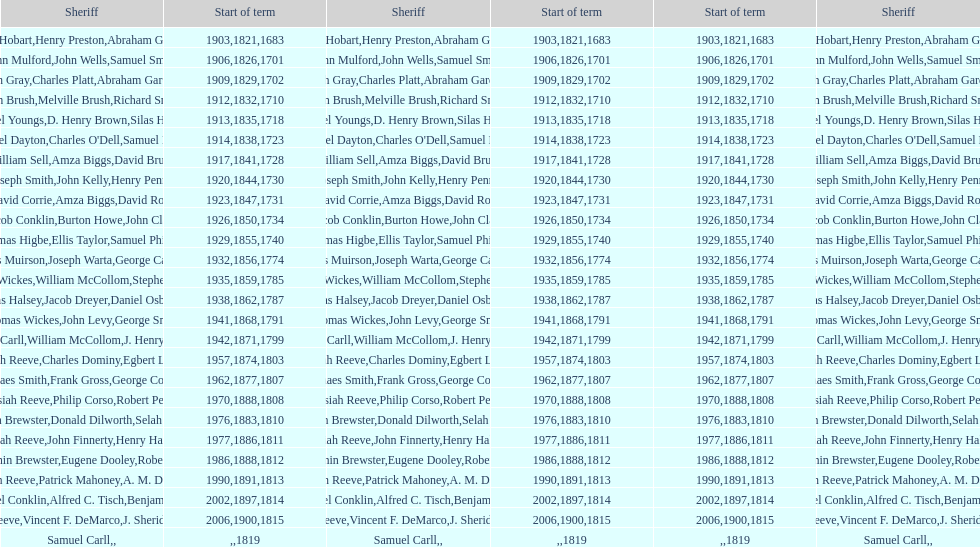Would you mind parsing the complete table? {'header': ['Sheriff', 'Start of term', 'Sheriff', 'Start of term', 'Start of term', 'Sheriff'], 'rows': [['Josiah Hobart', '1903', 'Henry Preston', '1821', '1683', 'Abraham Gardiner'], ['John Mulford', '1906', 'John Wells', '1826', '1701', 'Samuel Smith'], ['Hugh Gray', '1909', 'Charles Platt', '1829', '1702', 'Abraham Gardiner'], ['John Brush', '1912', 'Melville Brush', '1832', '1710', 'Richard Smith'], ['Daniel Youngs', '1913', 'D. Henry Brown', '1835', '1718', 'Silas Horton'], ['Samuel Dayton', '1914', "Charles O'Dell", '1838', '1723', 'Samuel Miller'], ['William Sell', '1917', 'Amza Biggs', '1841', '1728', 'David Brush'], ['Joseph Smith', '1920', 'John Kelly', '1844', '1730', 'Henry Penny'], ['David Corrie', '1923', 'Amza Biggs', '1847', '1731', 'David Rose'], ['Jacob Conklin', '1926', 'Burton Howe', '1850', '1734', 'John Clark'], ['Thomas Higbe', '1929', 'Ellis Taylor', '1855', '1740', 'Samuel Phillips'], ['James Muirson', '1932', 'Joseph Warta', '1856', '1774', 'George Carman'], ['Thomas Wickes', '1935', 'William McCollom', '1859', '1785', 'Stephen Wilson'], ['Silas Halsey', '1938', 'Jacob Dreyer', '1862', '1787', 'Daniel Osborn'], ['Thomas Wickes', '1941', 'John Levy', '1868', '1791', 'George Smith'], ['Phinaes Carll', '1942', 'William McCollom', '1871', '1799', 'J. Henry Perkins'], ['Josiah Reeve', '1957', 'Charles Dominy', '1874', '1803', 'Egbert Lewis'], ['Phinaes Smith', '1962', 'Frank Gross', '1877', '1807', 'George Cooper'], ['Josiah Reeve', '1970', 'Philip Corso', '1888', '1808', 'Robert Petty'], ['Benjamin Brewster', '1976', 'Donald Dilworth', '1883', '1810', 'Selah Brewster'], ['Josiah Reeve', '1977', 'John Finnerty', '1886', '1811', 'Henry Halsey'], ['Benjamin Brewster', '1986', 'Eugene Dooley', '1888', '1812', 'Robert Petty'], ['Josiah Reeve', '1990', 'Patrick Mahoney', '1891', '1813', 'A. M. Darling'], ['Nathaniel Conklin', '2002', 'Alfred C. Tisch', '1897', '1814', 'Benjamin Wood'], ['Josiah Reeve', '2006', 'Vincent F. DeMarco', '1900', '1815', 'J. Sheridan Wells'], ['Samuel Carll', '', '', '', '1819', '']]} When did benjamin brewster serve his second term? 1812. 